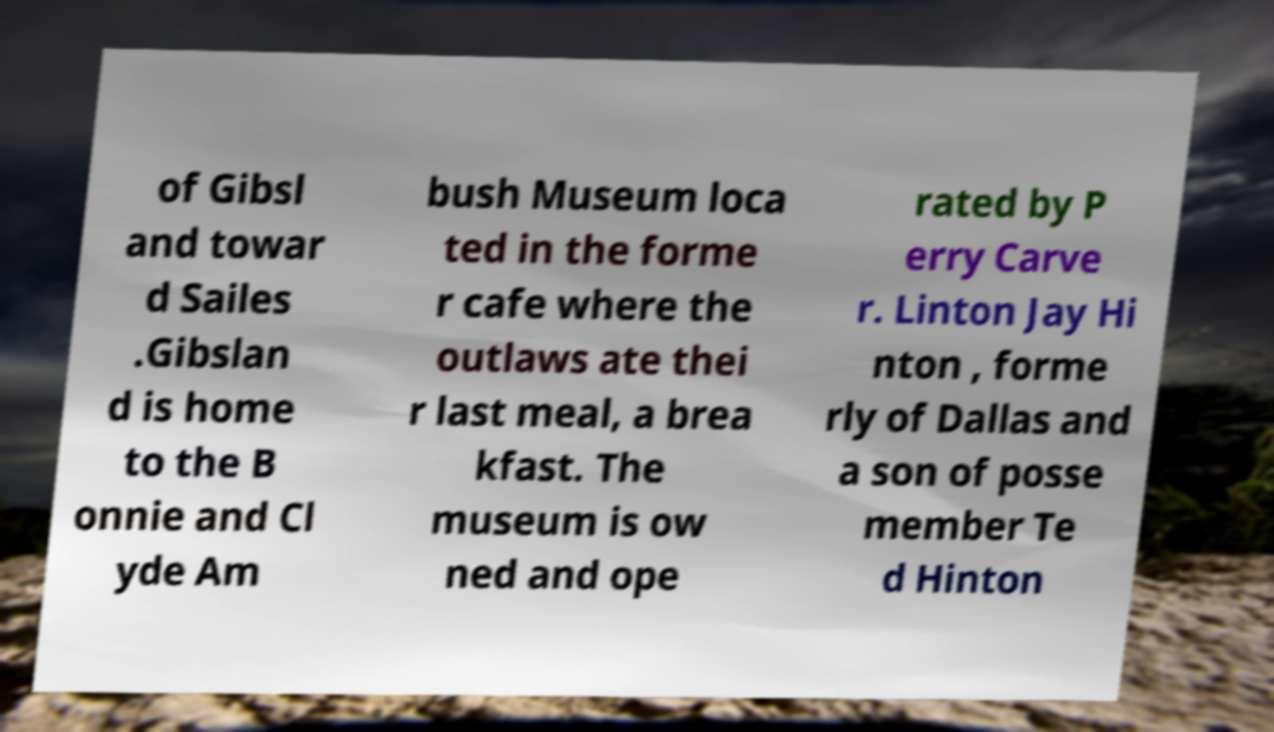Please read and relay the text visible in this image. What does it say? of Gibsl and towar d Sailes .Gibslan d is home to the B onnie and Cl yde Am bush Museum loca ted in the forme r cafe where the outlaws ate thei r last meal, a brea kfast. The museum is ow ned and ope rated by P erry Carve r. Linton Jay Hi nton , forme rly of Dallas and a son of posse member Te d Hinton 